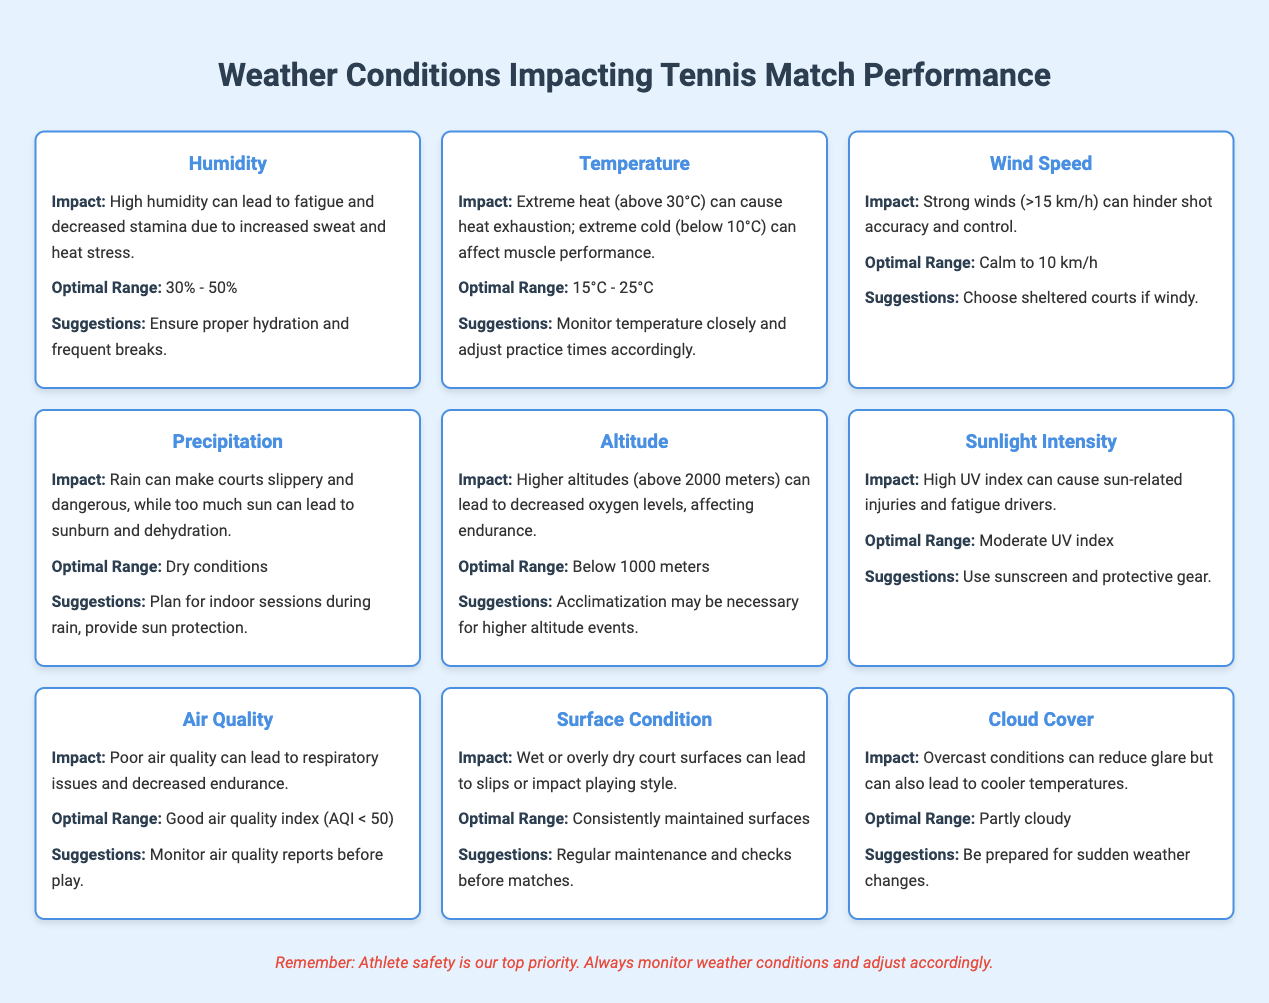What is the optimal humidity range for tennis matches? The optimal humidity range is found in the "Optimal Range" section for "Humidity," which states 30% - 50%.
Answer: 30% - 50% How does high temperature impact tennis performance? The impact of high temperature is detailed under "Temperature," indicating that extreme heat (above 30°C) can cause heat exhaustion.
Answer: Extreme heat can cause heat exhaustion Is the optimal air quality index (AQI) greater than 50? By reviewing the "Optimal Range" entry for "Air Quality," it clearly states that a good air quality index is AQI < 50, therefore it is false.
Answer: No What conditions should be expected when the wind speed is above 15 km/h? The entry for "Wind Speed" notes that strong winds (>15 km/h) can hinder shot accuracy and control, which indicates negative impacts on performance.
Answer: Hinders shot accuracy and control If the temperature is at 27°C and humidity is at 40%, are those conditions optimal for performance? From the entries for both "Temperature" and "Humidity," 27°C falls within the optimal range of 15°C - 25°C, but 40% humidity is within the optimal range of 30% - 50%. Thus, the overall conditions are not fully optimal.
Answer: No What is the combined impact of poor air quality and high humidity? Poor air quality leads to respiratory issues, and high humidity can induce fatigue and decreased stamina. When combined, athletes may face overlapping effects of reduced endurance and increased fatigue, severely impacting performance.
Answer: Decreased performance due to fatigue and respiratory issues Which weather condition has the recommendation to plan for indoor sessions? The "Precipitation" section specifies that rain can make courts slippery and recommends planning indoor sessions during rain.
Answer: Precipitation When might acclimatization be required according to the table? Under the "Altitude" entry, it mentions that acclimatization may be necessary for higher altitude events, specifically above 2000 meters.
Answer: Above 2000 meters What is the optimal range for sunlight intensity to avoid injuries? The "Optimal Range" for "Sunlight Intensity" indicates a moderate UV index is ideal for avoiding sun-related injuries.
Answer: Moderate UV index 